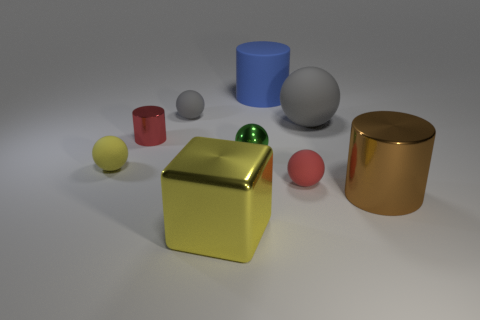Subtract all red matte spheres. How many spheres are left? 4 Subtract all red cubes. How many gray spheres are left? 2 Subtract 2 spheres. How many spheres are left? 3 Subtract all green spheres. How many spheres are left? 4 Subtract all cylinders. How many objects are left? 6 Subtract all yellow spheres. Subtract all green cylinders. How many spheres are left? 4 Subtract 0 cyan cylinders. How many objects are left? 9 Subtract all large blue cylinders. Subtract all big cyan metal cylinders. How many objects are left? 8 Add 7 large yellow metallic objects. How many large yellow metallic objects are left? 8 Add 4 big blue things. How many big blue things exist? 5 